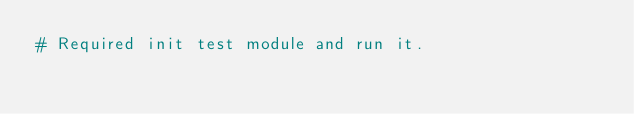Convert code to text. <code><loc_0><loc_0><loc_500><loc_500><_Python_># Required init test module and run it.</code> 